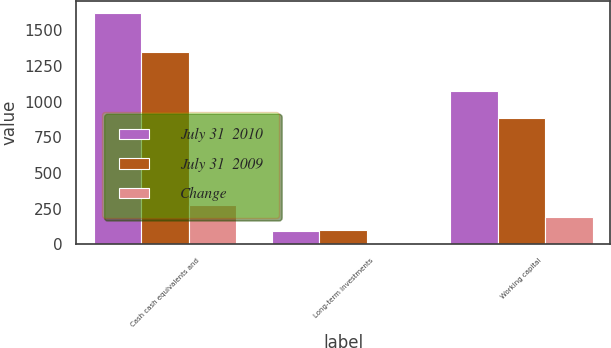Convert chart to OTSL. <chart><loc_0><loc_0><loc_500><loc_500><stacked_bar_chart><ecel><fcel>Cash cash equivalents and<fcel>Long-term investments<fcel>Working capital<nl><fcel>July 31  2010<fcel>1622<fcel>91<fcel>1074<nl><fcel>July 31  2009<fcel>1347<fcel>97<fcel>884<nl><fcel>Change<fcel>275<fcel>6<fcel>190<nl></chart> 